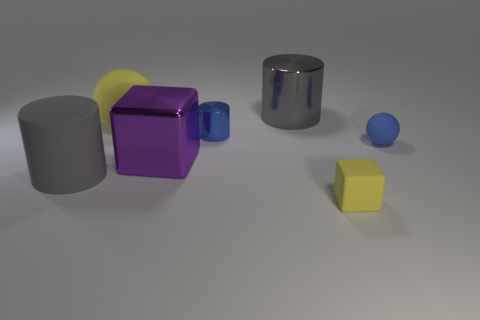If these objects were part of a simple physics experiment, what could be demonstrated? Given their varied shapes, sizes, and apparent materials, these objects could be used to demonstrate basic principles of physics such as geometry, mass, density, and the behavior of light (reflection, absorption, and shadow casting). Rolling the cylindrical objects could illustrate concepts of rotation and angular momentum, while stacking the cubes might demonstrate balance and center of gravity. 